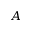Convert formula to latex. <formula><loc_0><loc_0><loc_500><loc_500>A</formula> 